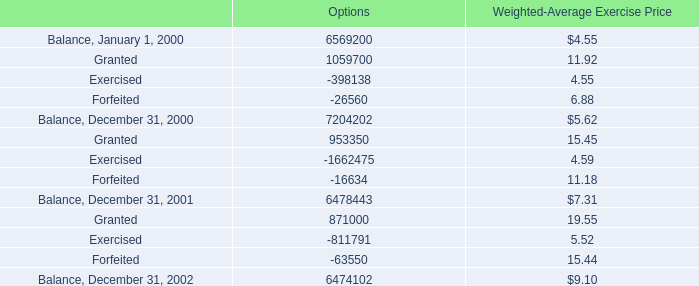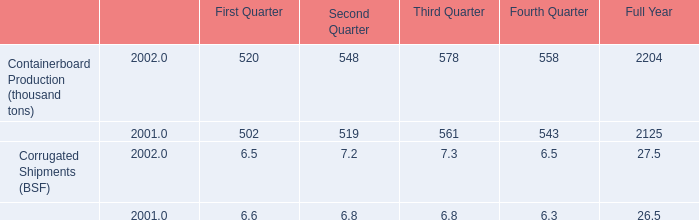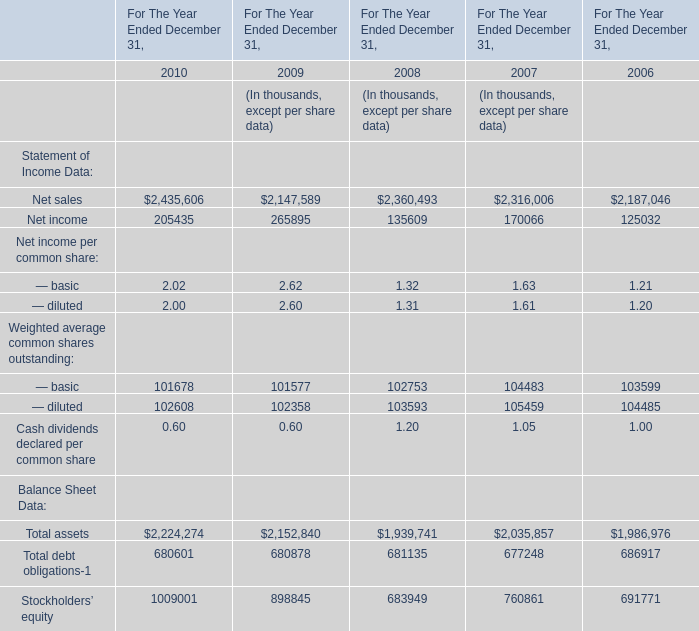What's the average of Net income of For The Year Ended December 31, 2010, and Balance, December 31, 2001 of Options ? 
Computations: ((205435.0 + 6478443.0) / 2)
Answer: 3341939.0. 